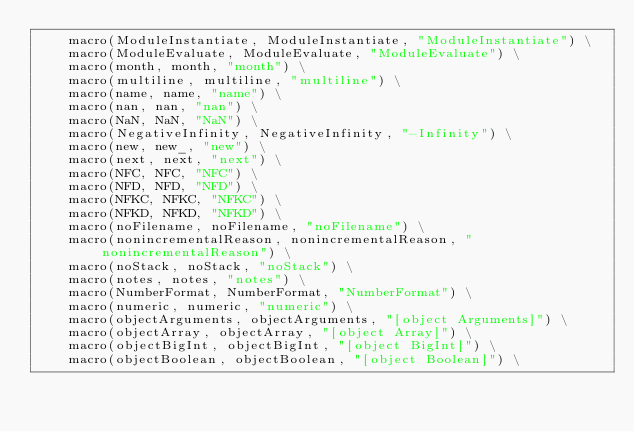<code> <loc_0><loc_0><loc_500><loc_500><_C_>    macro(ModuleInstantiate, ModuleInstantiate, "ModuleInstantiate") \
    macro(ModuleEvaluate, ModuleEvaluate, "ModuleEvaluate") \
    macro(month, month, "month") \
    macro(multiline, multiline, "multiline") \
    macro(name, name, "name") \
    macro(nan, nan, "nan") \
    macro(NaN, NaN, "NaN") \
    macro(NegativeInfinity, NegativeInfinity, "-Infinity") \
    macro(new, new_, "new") \
    macro(next, next, "next") \
    macro(NFC, NFC, "NFC") \
    macro(NFD, NFD, "NFD") \
    macro(NFKC, NFKC, "NFKC") \
    macro(NFKD, NFKD, "NFKD") \
    macro(noFilename, noFilename, "noFilename") \
    macro(nonincrementalReason, nonincrementalReason, "nonincrementalReason") \
    macro(noStack, noStack, "noStack") \
    macro(notes, notes, "notes") \
    macro(NumberFormat, NumberFormat, "NumberFormat") \
    macro(numeric, numeric, "numeric") \
    macro(objectArguments, objectArguments, "[object Arguments]") \
    macro(objectArray, objectArray, "[object Array]") \
    macro(objectBigInt, objectBigInt, "[object BigInt]") \
    macro(objectBoolean, objectBoolean, "[object Boolean]") \</code> 